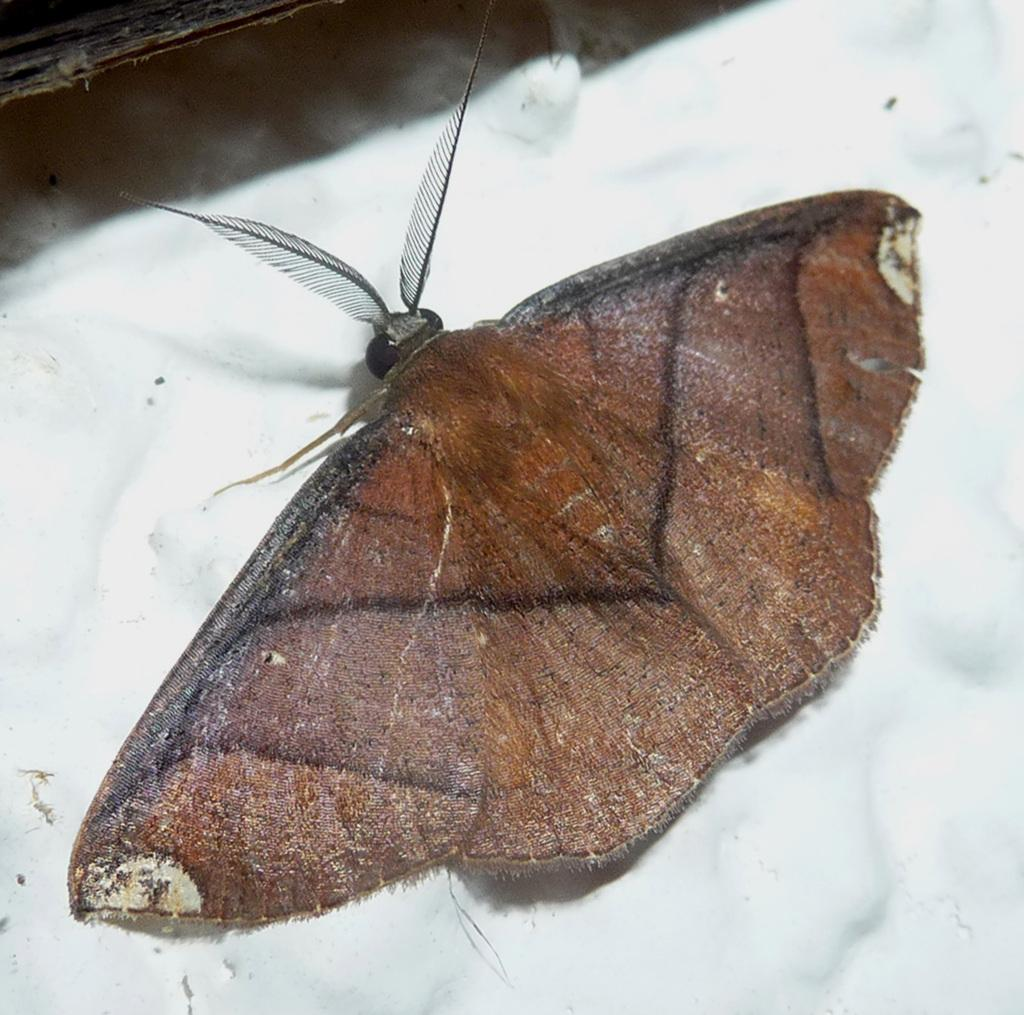What type of creature can be seen in the image? There is an insect in the image. What color is the background of the image? The background of the image is white. What type of substance is the insect holding in the image? There is no substance visible in the image; only the insect and the white background can be seen. 